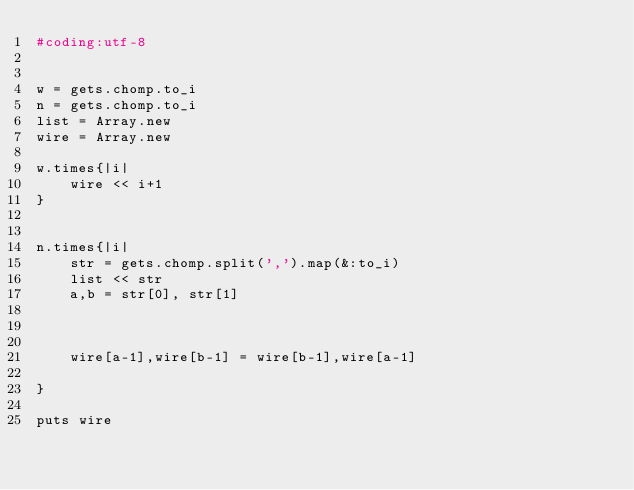Convert code to text. <code><loc_0><loc_0><loc_500><loc_500><_Ruby_>#coding:utf-8


w = gets.chomp.to_i
n = gets.chomp.to_i
list = Array.new
wire = Array.new

w.times{|i|
	wire << i+1
}


n.times{|i|
	str = gets.chomp.split(',').map(&:to_i)
	list << str
	a,b = str[0], str[1]

	

	wire[a-1],wire[b-1] = wire[b-1],wire[a-1]

}

puts wire</code> 